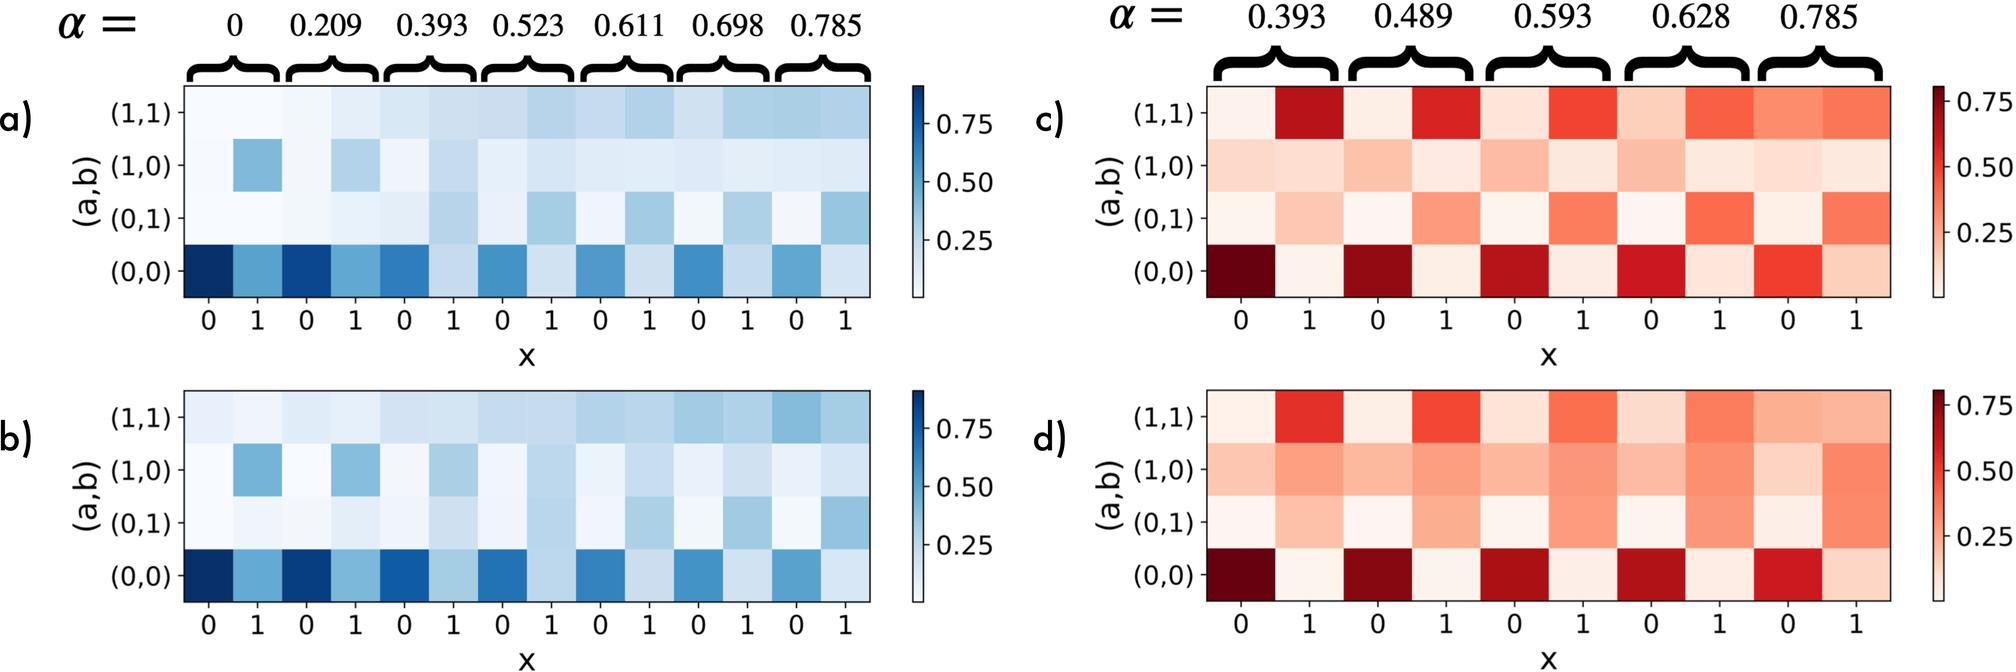Which figure set shows a higher maximum correlation value between (a,b) when 'x' equals 1? A. Figures a and b B. Figures c and d C. Both sets show equal correlation values. D. The figures do not provide information about specific values of 'x'. At 'x' equals 1, upon examining the color intensities in the heatmaps, figures c and d exhibit darker red shades compared to the lighter hues in figures a and b. The degree of darkness in a heatmap typically corresponds to higher values, hence it suggests that the correlation values are higher in figures c and d at this specific point. This visual information leads us to conclude that option B, figures c and d, displays a higher maximum correlation value at 'x' equals 1. The color gradient on the right-hand side of each heatmap provides a guide to interpreting these values, confirming the observation. 